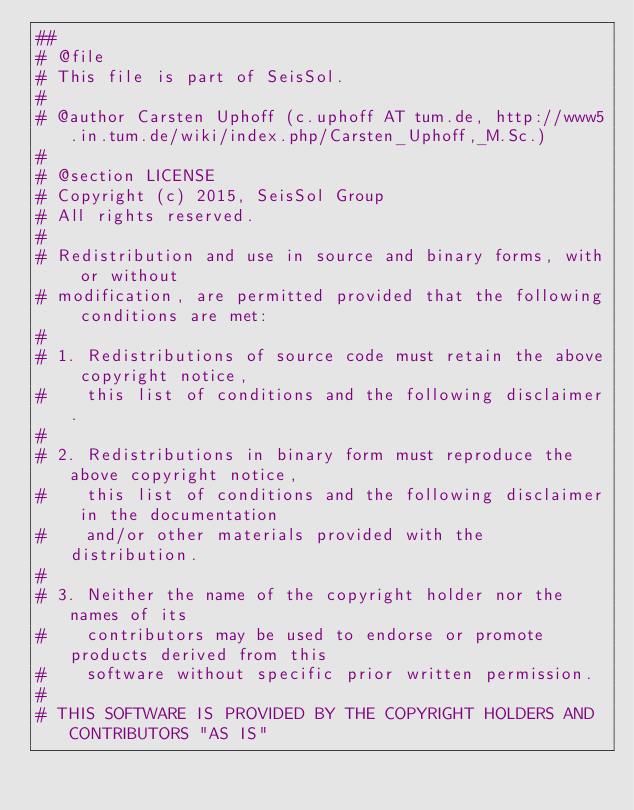Convert code to text. <code><loc_0><loc_0><loc_500><loc_500><_Python_>##
# @file
# This file is part of SeisSol.
#
# @author Carsten Uphoff (c.uphoff AT tum.de, http://www5.in.tum.de/wiki/index.php/Carsten_Uphoff,_M.Sc.)
#
# @section LICENSE
# Copyright (c) 2015, SeisSol Group
# All rights reserved.
#
# Redistribution and use in source and binary forms, with or without
# modification, are permitted provided that the following conditions are met:
#
# 1. Redistributions of source code must retain the above copyright notice,
#    this list of conditions and the following disclaimer.
#
# 2. Redistributions in binary form must reproduce the above copyright notice,
#    this list of conditions and the following disclaimer in the documentation
#    and/or other materials provided with the distribution.
#
# 3. Neither the name of the copyright holder nor the names of its
#    contributors may be used to endorse or promote products derived from this
#    software without specific prior written permission.
#
# THIS SOFTWARE IS PROVIDED BY THE COPYRIGHT HOLDERS AND CONTRIBUTORS "AS IS"</code> 